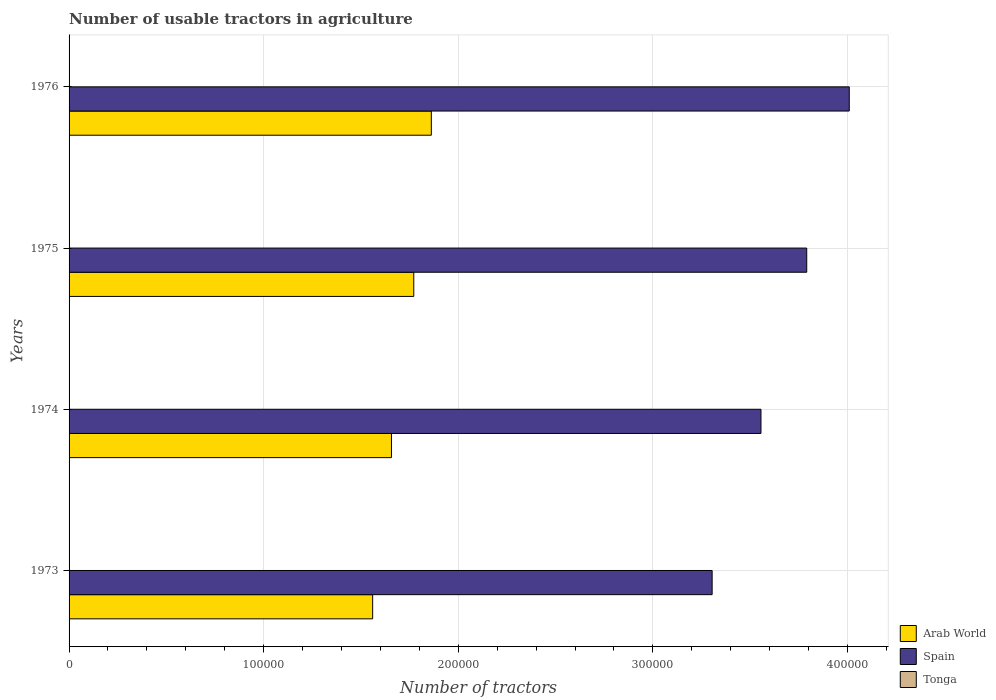How many different coloured bars are there?
Ensure brevity in your answer.  3. How many groups of bars are there?
Your answer should be compact. 4. Are the number of bars on each tick of the Y-axis equal?
Provide a succinct answer. Yes. How many bars are there on the 2nd tick from the bottom?
Provide a succinct answer. 3. In how many cases, is the number of bars for a given year not equal to the number of legend labels?
Make the answer very short. 0. What is the number of usable tractors in agriculture in Spain in 1975?
Make the answer very short. 3.79e+05. Across all years, what is the maximum number of usable tractors in agriculture in Arab World?
Your response must be concise. 1.86e+05. Across all years, what is the minimum number of usable tractors in agriculture in Arab World?
Make the answer very short. 1.56e+05. In which year was the number of usable tractors in agriculture in Spain maximum?
Offer a very short reply. 1976. In which year was the number of usable tractors in agriculture in Spain minimum?
Give a very brief answer. 1973. What is the total number of usable tractors in agriculture in Arab World in the graph?
Your answer should be very brief. 6.85e+05. What is the difference between the number of usable tractors in agriculture in Arab World in 1974 and that in 1976?
Keep it short and to the point. -2.05e+04. What is the difference between the number of usable tractors in agriculture in Spain in 1976 and the number of usable tractors in agriculture in Tonga in 1974?
Keep it short and to the point. 4.01e+05. What is the average number of usable tractors in agriculture in Tonga per year?
Provide a short and direct response. 108.75. In the year 1973, what is the difference between the number of usable tractors in agriculture in Arab World and number of usable tractors in agriculture in Tonga?
Your answer should be very brief. 1.56e+05. In how many years, is the number of usable tractors in agriculture in Arab World greater than 360000 ?
Offer a very short reply. 0. What is the ratio of the number of usable tractors in agriculture in Spain in 1974 to that in 1975?
Give a very brief answer. 0.94. Is the number of usable tractors in agriculture in Spain in 1974 less than that in 1975?
Provide a succinct answer. Yes. What is the difference between the highest and the second highest number of usable tractors in agriculture in Arab World?
Ensure brevity in your answer.  9025. What is the difference between the highest and the lowest number of usable tractors in agriculture in Spain?
Provide a succinct answer. 7.05e+04. In how many years, is the number of usable tractors in agriculture in Spain greater than the average number of usable tractors in agriculture in Spain taken over all years?
Your answer should be very brief. 2. Is the sum of the number of usable tractors in agriculture in Arab World in 1974 and 1976 greater than the maximum number of usable tractors in agriculture in Tonga across all years?
Provide a short and direct response. Yes. What does the 1st bar from the top in 1973 represents?
Make the answer very short. Tonga. What does the 3rd bar from the bottom in 1974 represents?
Your response must be concise. Tonga. How many bars are there?
Keep it short and to the point. 12. How many years are there in the graph?
Offer a very short reply. 4. What is the difference between two consecutive major ticks on the X-axis?
Provide a succinct answer. 1.00e+05. Does the graph contain any zero values?
Offer a very short reply. No. Does the graph contain grids?
Offer a terse response. Yes. What is the title of the graph?
Make the answer very short. Number of usable tractors in agriculture. Does "Belize" appear as one of the legend labels in the graph?
Provide a succinct answer. No. What is the label or title of the X-axis?
Keep it short and to the point. Number of tractors. What is the Number of tractors of Arab World in 1973?
Make the answer very short. 1.56e+05. What is the Number of tractors of Spain in 1973?
Provide a short and direct response. 3.30e+05. What is the Number of tractors in Tonga in 1973?
Offer a terse response. 105. What is the Number of tractors of Arab World in 1974?
Offer a very short reply. 1.66e+05. What is the Number of tractors in Spain in 1974?
Your answer should be very brief. 3.56e+05. What is the Number of tractors in Tonga in 1974?
Ensure brevity in your answer.  110. What is the Number of tractors of Arab World in 1975?
Give a very brief answer. 1.77e+05. What is the Number of tractors in Spain in 1975?
Keep it short and to the point. 3.79e+05. What is the Number of tractors in Tonga in 1975?
Ensure brevity in your answer.  110. What is the Number of tractors in Arab World in 1976?
Keep it short and to the point. 1.86e+05. What is the Number of tractors in Spain in 1976?
Provide a short and direct response. 4.01e+05. What is the Number of tractors of Tonga in 1976?
Ensure brevity in your answer.  110. Across all years, what is the maximum Number of tractors in Arab World?
Offer a terse response. 1.86e+05. Across all years, what is the maximum Number of tractors in Spain?
Your answer should be very brief. 4.01e+05. Across all years, what is the maximum Number of tractors of Tonga?
Give a very brief answer. 110. Across all years, what is the minimum Number of tractors in Arab World?
Provide a succinct answer. 1.56e+05. Across all years, what is the minimum Number of tractors of Spain?
Provide a short and direct response. 3.30e+05. Across all years, what is the minimum Number of tractors in Tonga?
Keep it short and to the point. 105. What is the total Number of tractors of Arab World in the graph?
Offer a terse response. 6.85e+05. What is the total Number of tractors in Spain in the graph?
Your answer should be compact. 1.47e+06. What is the total Number of tractors in Tonga in the graph?
Give a very brief answer. 435. What is the difference between the Number of tractors in Arab World in 1973 and that in 1974?
Your response must be concise. -9652. What is the difference between the Number of tractors in Spain in 1973 and that in 1974?
Your answer should be compact. -2.51e+04. What is the difference between the Number of tractors in Tonga in 1973 and that in 1974?
Your answer should be very brief. -5. What is the difference between the Number of tractors in Arab World in 1973 and that in 1975?
Offer a very short reply. -2.11e+04. What is the difference between the Number of tractors of Spain in 1973 and that in 1975?
Keep it short and to the point. -4.86e+04. What is the difference between the Number of tractors of Arab World in 1973 and that in 1976?
Offer a terse response. -3.01e+04. What is the difference between the Number of tractors of Spain in 1973 and that in 1976?
Make the answer very short. -7.05e+04. What is the difference between the Number of tractors of Arab World in 1974 and that in 1975?
Offer a very short reply. -1.15e+04. What is the difference between the Number of tractors of Spain in 1974 and that in 1975?
Make the answer very short. -2.35e+04. What is the difference between the Number of tractors of Tonga in 1974 and that in 1975?
Provide a succinct answer. 0. What is the difference between the Number of tractors of Arab World in 1974 and that in 1976?
Ensure brevity in your answer.  -2.05e+04. What is the difference between the Number of tractors of Spain in 1974 and that in 1976?
Provide a short and direct response. -4.54e+04. What is the difference between the Number of tractors in Arab World in 1975 and that in 1976?
Offer a very short reply. -9025. What is the difference between the Number of tractors of Spain in 1975 and that in 1976?
Your response must be concise. -2.19e+04. What is the difference between the Number of tractors in Tonga in 1975 and that in 1976?
Your answer should be very brief. 0. What is the difference between the Number of tractors of Arab World in 1973 and the Number of tractors of Spain in 1974?
Give a very brief answer. -2.00e+05. What is the difference between the Number of tractors in Arab World in 1973 and the Number of tractors in Tonga in 1974?
Provide a succinct answer. 1.56e+05. What is the difference between the Number of tractors in Spain in 1973 and the Number of tractors in Tonga in 1974?
Your answer should be very brief. 3.30e+05. What is the difference between the Number of tractors of Arab World in 1973 and the Number of tractors of Spain in 1975?
Make the answer very short. -2.23e+05. What is the difference between the Number of tractors of Arab World in 1973 and the Number of tractors of Tonga in 1975?
Your response must be concise. 1.56e+05. What is the difference between the Number of tractors in Spain in 1973 and the Number of tractors in Tonga in 1975?
Provide a succinct answer. 3.30e+05. What is the difference between the Number of tractors in Arab World in 1973 and the Number of tractors in Spain in 1976?
Your response must be concise. -2.45e+05. What is the difference between the Number of tractors in Arab World in 1973 and the Number of tractors in Tonga in 1976?
Offer a terse response. 1.56e+05. What is the difference between the Number of tractors in Spain in 1973 and the Number of tractors in Tonga in 1976?
Offer a very short reply. 3.30e+05. What is the difference between the Number of tractors of Arab World in 1974 and the Number of tractors of Spain in 1975?
Your response must be concise. -2.13e+05. What is the difference between the Number of tractors of Arab World in 1974 and the Number of tractors of Tonga in 1975?
Offer a very short reply. 1.66e+05. What is the difference between the Number of tractors of Spain in 1974 and the Number of tractors of Tonga in 1975?
Your response must be concise. 3.55e+05. What is the difference between the Number of tractors of Arab World in 1974 and the Number of tractors of Spain in 1976?
Make the answer very short. -2.35e+05. What is the difference between the Number of tractors in Arab World in 1974 and the Number of tractors in Tonga in 1976?
Ensure brevity in your answer.  1.66e+05. What is the difference between the Number of tractors in Spain in 1974 and the Number of tractors in Tonga in 1976?
Offer a very short reply. 3.55e+05. What is the difference between the Number of tractors in Arab World in 1975 and the Number of tractors in Spain in 1976?
Your response must be concise. -2.24e+05. What is the difference between the Number of tractors in Arab World in 1975 and the Number of tractors in Tonga in 1976?
Provide a short and direct response. 1.77e+05. What is the difference between the Number of tractors in Spain in 1975 and the Number of tractors in Tonga in 1976?
Your answer should be very brief. 3.79e+05. What is the average Number of tractors of Arab World per year?
Your response must be concise. 1.71e+05. What is the average Number of tractors in Spain per year?
Your answer should be very brief. 3.67e+05. What is the average Number of tractors of Tonga per year?
Your answer should be compact. 108.75. In the year 1973, what is the difference between the Number of tractors of Arab World and Number of tractors of Spain?
Offer a terse response. -1.74e+05. In the year 1973, what is the difference between the Number of tractors of Arab World and Number of tractors of Tonga?
Your response must be concise. 1.56e+05. In the year 1973, what is the difference between the Number of tractors in Spain and Number of tractors in Tonga?
Provide a short and direct response. 3.30e+05. In the year 1974, what is the difference between the Number of tractors in Arab World and Number of tractors in Spain?
Your response must be concise. -1.90e+05. In the year 1974, what is the difference between the Number of tractors of Arab World and Number of tractors of Tonga?
Provide a succinct answer. 1.66e+05. In the year 1974, what is the difference between the Number of tractors of Spain and Number of tractors of Tonga?
Offer a very short reply. 3.55e+05. In the year 1975, what is the difference between the Number of tractors of Arab World and Number of tractors of Spain?
Your answer should be very brief. -2.02e+05. In the year 1975, what is the difference between the Number of tractors in Arab World and Number of tractors in Tonga?
Provide a succinct answer. 1.77e+05. In the year 1975, what is the difference between the Number of tractors in Spain and Number of tractors in Tonga?
Offer a very short reply. 3.79e+05. In the year 1976, what is the difference between the Number of tractors in Arab World and Number of tractors in Spain?
Ensure brevity in your answer.  -2.15e+05. In the year 1976, what is the difference between the Number of tractors of Arab World and Number of tractors of Tonga?
Keep it short and to the point. 1.86e+05. In the year 1976, what is the difference between the Number of tractors of Spain and Number of tractors of Tonga?
Your response must be concise. 4.01e+05. What is the ratio of the Number of tractors in Arab World in 1973 to that in 1974?
Ensure brevity in your answer.  0.94. What is the ratio of the Number of tractors in Spain in 1973 to that in 1974?
Give a very brief answer. 0.93. What is the ratio of the Number of tractors of Tonga in 1973 to that in 1974?
Offer a very short reply. 0.95. What is the ratio of the Number of tractors of Arab World in 1973 to that in 1975?
Provide a succinct answer. 0.88. What is the ratio of the Number of tractors in Spain in 1973 to that in 1975?
Give a very brief answer. 0.87. What is the ratio of the Number of tractors in Tonga in 1973 to that in 1975?
Your answer should be very brief. 0.95. What is the ratio of the Number of tractors of Arab World in 1973 to that in 1976?
Your answer should be very brief. 0.84. What is the ratio of the Number of tractors in Spain in 1973 to that in 1976?
Provide a short and direct response. 0.82. What is the ratio of the Number of tractors of Tonga in 1973 to that in 1976?
Your answer should be very brief. 0.95. What is the ratio of the Number of tractors in Arab World in 1974 to that in 1975?
Give a very brief answer. 0.94. What is the ratio of the Number of tractors of Spain in 1974 to that in 1975?
Provide a succinct answer. 0.94. What is the ratio of the Number of tractors in Tonga in 1974 to that in 1975?
Provide a succinct answer. 1. What is the ratio of the Number of tractors in Arab World in 1974 to that in 1976?
Make the answer very short. 0.89. What is the ratio of the Number of tractors of Spain in 1974 to that in 1976?
Provide a succinct answer. 0.89. What is the ratio of the Number of tractors in Arab World in 1975 to that in 1976?
Keep it short and to the point. 0.95. What is the ratio of the Number of tractors of Spain in 1975 to that in 1976?
Make the answer very short. 0.95. What is the ratio of the Number of tractors in Tonga in 1975 to that in 1976?
Provide a short and direct response. 1. What is the difference between the highest and the second highest Number of tractors of Arab World?
Provide a short and direct response. 9025. What is the difference between the highest and the second highest Number of tractors of Spain?
Keep it short and to the point. 2.19e+04. What is the difference between the highest and the lowest Number of tractors in Arab World?
Your answer should be compact. 3.01e+04. What is the difference between the highest and the lowest Number of tractors of Spain?
Your answer should be compact. 7.05e+04. 